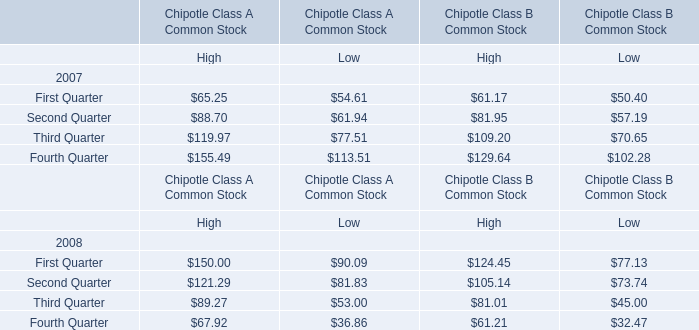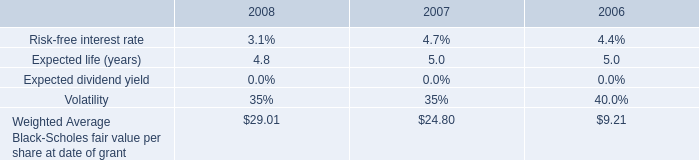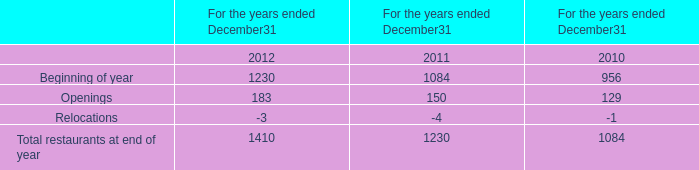what was the percent of the increase in other income other income for the utility from 2005 to 2006 
Computations: ((156 - 111) / 111)
Answer: 0.40541. 